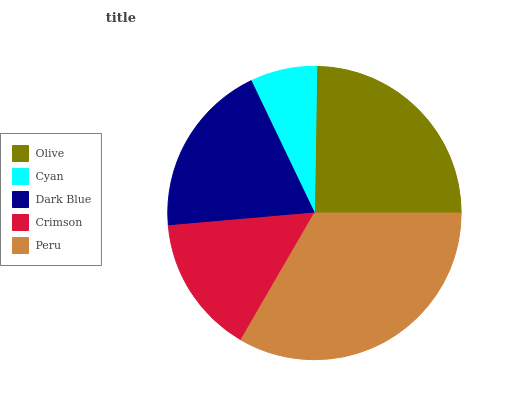Is Cyan the minimum?
Answer yes or no. Yes. Is Peru the maximum?
Answer yes or no. Yes. Is Dark Blue the minimum?
Answer yes or no. No. Is Dark Blue the maximum?
Answer yes or no. No. Is Dark Blue greater than Cyan?
Answer yes or no. Yes. Is Cyan less than Dark Blue?
Answer yes or no. Yes. Is Cyan greater than Dark Blue?
Answer yes or no. No. Is Dark Blue less than Cyan?
Answer yes or no. No. Is Dark Blue the high median?
Answer yes or no. Yes. Is Dark Blue the low median?
Answer yes or no. Yes. Is Olive the high median?
Answer yes or no. No. Is Peru the low median?
Answer yes or no. No. 